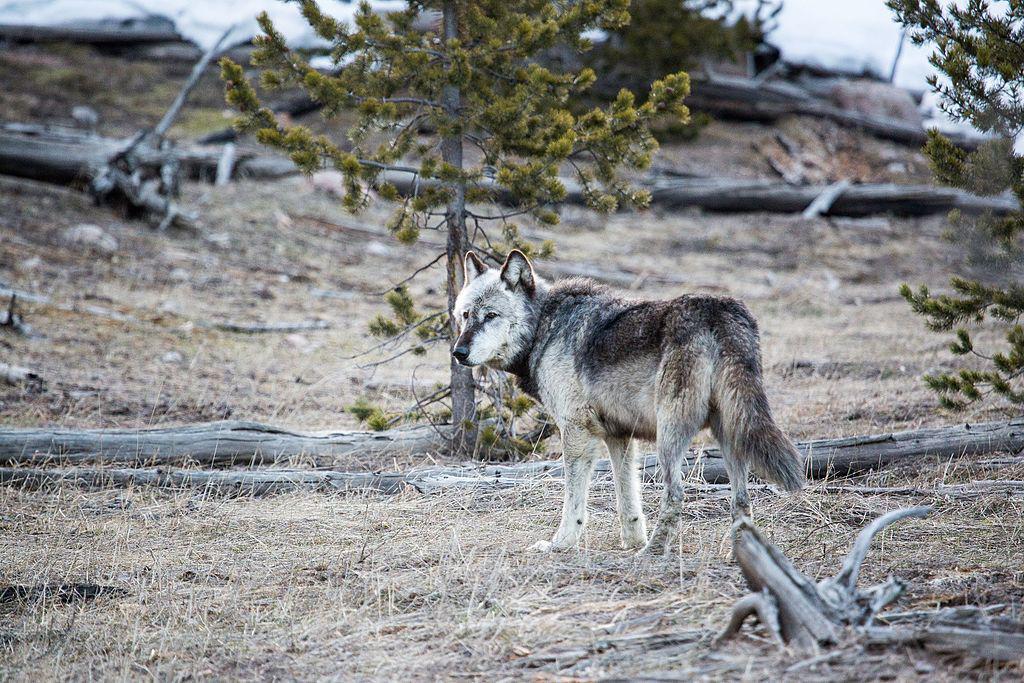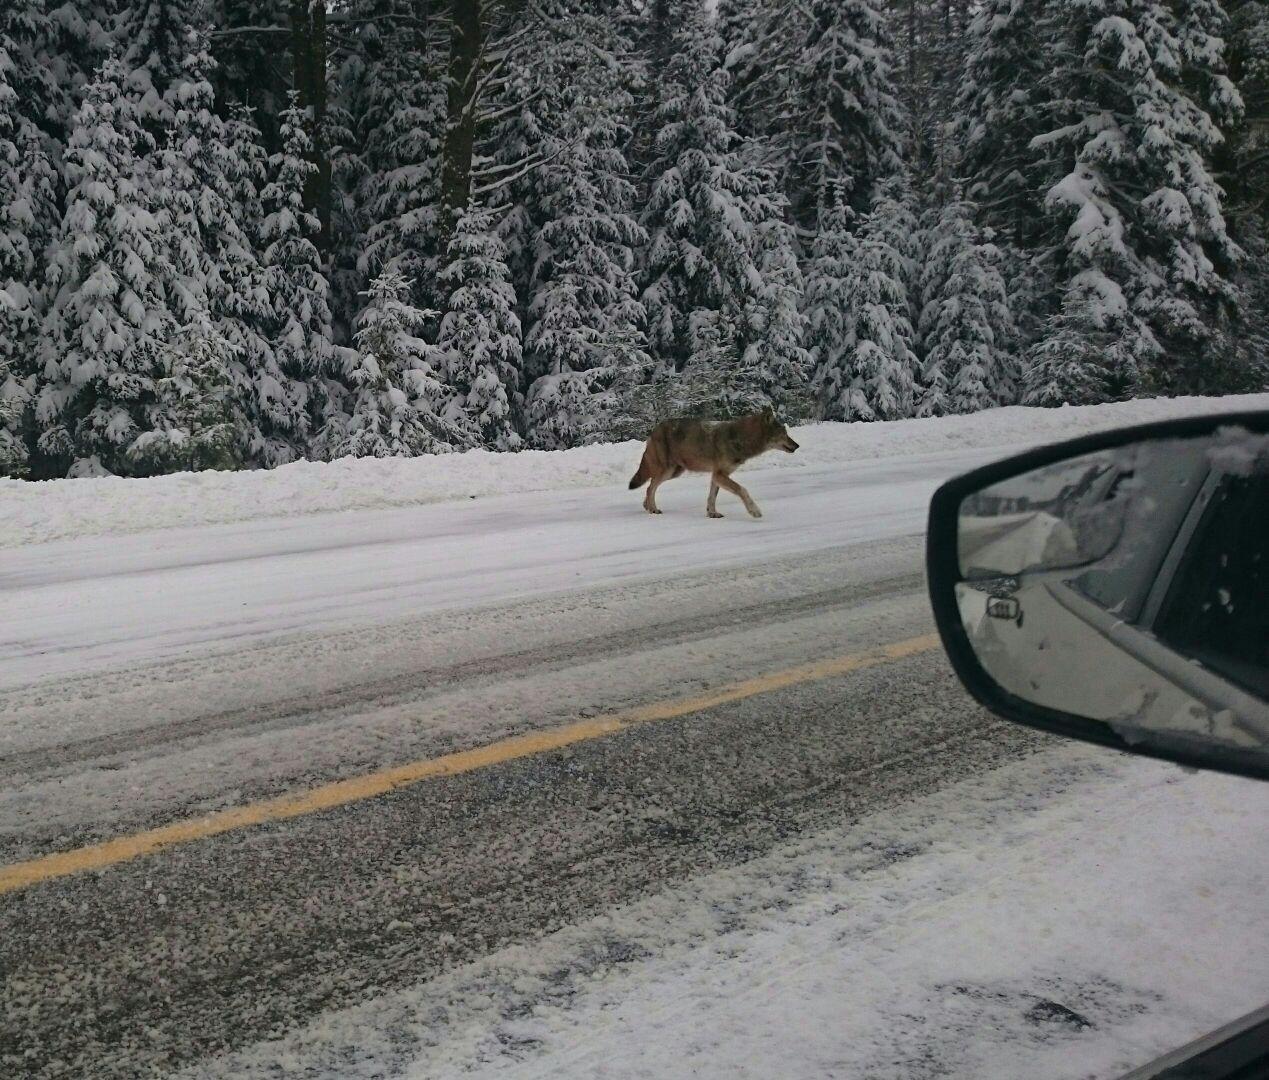The first image is the image on the left, the second image is the image on the right. Examine the images to the left and right. Is the description "One image features a wolf on snowy ground, and the other includes a body of water and at least one wolf." accurate? Answer yes or no. No. The first image is the image on the left, the second image is the image on the right. Considering the images on both sides, is "A single wolf is in a watery area in the image on the right." valid? Answer yes or no. No. 